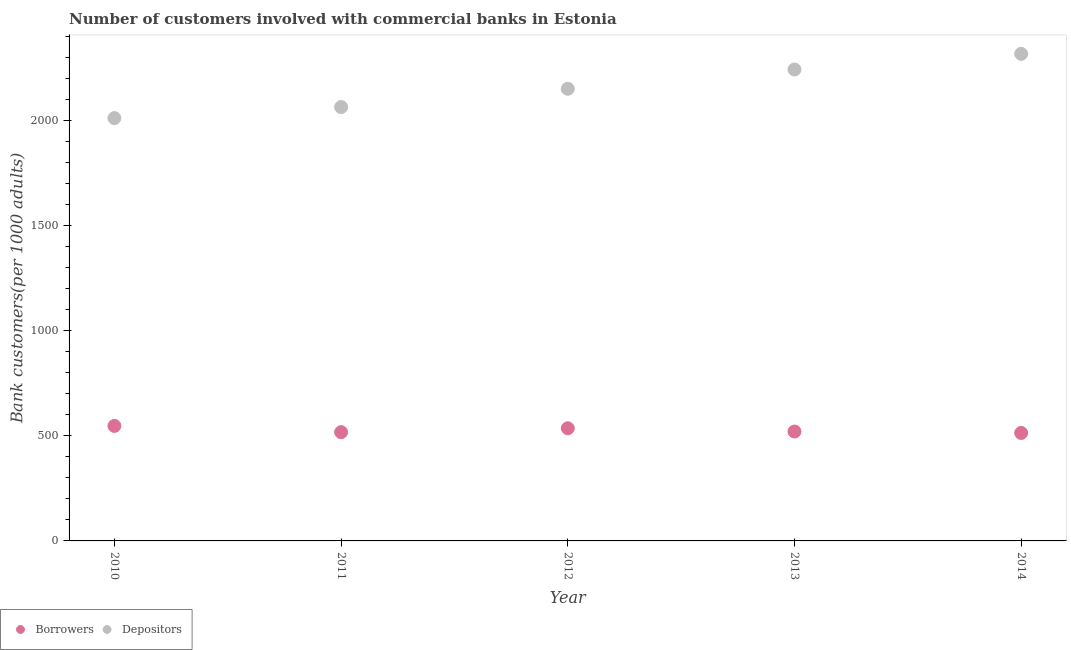How many different coloured dotlines are there?
Give a very brief answer. 2. Is the number of dotlines equal to the number of legend labels?
Make the answer very short. Yes. What is the number of depositors in 2011?
Provide a succinct answer. 2064.84. Across all years, what is the maximum number of borrowers?
Offer a very short reply. 547.32. Across all years, what is the minimum number of depositors?
Make the answer very short. 2012.21. What is the total number of borrowers in the graph?
Offer a terse response. 2635.42. What is the difference between the number of depositors in 2011 and that in 2013?
Your answer should be compact. -178.61. What is the difference between the number of borrowers in 2014 and the number of depositors in 2012?
Keep it short and to the point. -1637.88. What is the average number of depositors per year?
Give a very brief answer. 2158.03. In the year 2010, what is the difference between the number of depositors and number of borrowers?
Offer a very short reply. 1464.89. In how many years, is the number of borrowers greater than 2100?
Give a very brief answer. 0. What is the ratio of the number of borrowers in 2010 to that in 2012?
Offer a terse response. 1.02. Is the number of borrowers in 2010 less than that in 2014?
Provide a succinct answer. No. What is the difference between the highest and the second highest number of depositors?
Your answer should be very brief. 74.57. What is the difference between the highest and the lowest number of borrowers?
Your response must be concise. 33.53. Is the sum of the number of depositors in 2010 and 2014 greater than the maximum number of borrowers across all years?
Provide a succinct answer. Yes. Does the number of borrowers monotonically increase over the years?
Offer a terse response. No. Is the number of depositors strictly greater than the number of borrowers over the years?
Offer a very short reply. Yes. Is the number of borrowers strictly less than the number of depositors over the years?
Offer a terse response. Yes. How many dotlines are there?
Provide a short and direct response. 2. How many years are there in the graph?
Give a very brief answer. 5. What is the difference between two consecutive major ticks on the Y-axis?
Make the answer very short. 500. Does the graph contain any zero values?
Provide a succinct answer. No. Where does the legend appear in the graph?
Offer a terse response. Bottom left. What is the title of the graph?
Keep it short and to the point. Number of customers involved with commercial banks in Estonia. What is the label or title of the X-axis?
Offer a very short reply. Year. What is the label or title of the Y-axis?
Provide a succinct answer. Bank customers(per 1000 adults). What is the Bank customers(per 1000 adults) in Borrowers in 2010?
Your answer should be very brief. 547.32. What is the Bank customers(per 1000 adults) of Depositors in 2010?
Your answer should be very brief. 2012.21. What is the Bank customers(per 1000 adults) in Borrowers in 2011?
Your answer should be very brief. 517.65. What is the Bank customers(per 1000 adults) of Depositors in 2011?
Provide a short and direct response. 2064.84. What is the Bank customers(per 1000 adults) of Borrowers in 2012?
Offer a terse response. 536.16. What is the Bank customers(per 1000 adults) of Depositors in 2012?
Make the answer very short. 2151.67. What is the Bank customers(per 1000 adults) in Borrowers in 2013?
Offer a terse response. 520.5. What is the Bank customers(per 1000 adults) of Depositors in 2013?
Your response must be concise. 2243.44. What is the Bank customers(per 1000 adults) in Borrowers in 2014?
Ensure brevity in your answer.  513.79. What is the Bank customers(per 1000 adults) in Depositors in 2014?
Your answer should be very brief. 2318.01. Across all years, what is the maximum Bank customers(per 1000 adults) of Borrowers?
Ensure brevity in your answer.  547.32. Across all years, what is the maximum Bank customers(per 1000 adults) in Depositors?
Offer a terse response. 2318.01. Across all years, what is the minimum Bank customers(per 1000 adults) in Borrowers?
Keep it short and to the point. 513.79. Across all years, what is the minimum Bank customers(per 1000 adults) in Depositors?
Make the answer very short. 2012.21. What is the total Bank customers(per 1000 adults) in Borrowers in the graph?
Keep it short and to the point. 2635.42. What is the total Bank customers(per 1000 adults) in Depositors in the graph?
Offer a very short reply. 1.08e+04. What is the difference between the Bank customers(per 1000 adults) of Borrowers in 2010 and that in 2011?
Provide a short and direct response. 29.67. What is the difference between the Bank customers(per 1000 adults) in Depositors in 2010 and that in 2011?
Your answer should be very brief. -52.62. What is the difference between the Bank customers(per 1000 adults) of Borrowers in 2010 and that in 2012?
Ensure brevity in your answer.  11.16. What is the difference between the Bank customers(per 1000 adults) of Depositors in 2010 and that in 2012?
Your answer should be very brief. -139.46. What is the difference between the Bank customers(per 1000 adults) of Borrowers in 2010 and that in 2013?
Provide a short and direct response. 26.82. What is the difference between the Bank customers(per 1000 adults) in Depositors in 2010 and that in 2013?
Offer a terse response. -231.23. What is the difference between the Bank customers(per 1000 adults) in Borrowers in 2010 and that in 2014?
Your response must be concise. 33.53. What is the difference between the Bank customers(per 1000 adults) of Depositors in 2010 and that in 2014?
Give a very brief answer. -305.8. What is the difference between the Bank customers(per 1000 adults) of Borrowers in 2011 and that in 2012?
Make the answer very short. -18.51. What is the difference between the Bank customers(per 1000 adults) of Depositors in 2011 and that in 2012?
Your response must be concise. -86.83. What is the difference between the Bank customers(per 1000 adults) of Borrowers in 2011 and that in 2013?
Ensure brevity in your answer.  -2.85. What is the difference between the Bank customers(per 1000 adults) in Depositors in 2011 and that in 2013?
Offer a terse response. -178.61. What is the difference between the Bank customers(per 1000 adults) in Borrowers in 2011 and that in 2014?
Make the answer very short. 3.86. What is the difference between the Bank customers(per 1000 adults) in Depositors in 2011 and that in 2014?
Provide a short and direct response. -253.17. What is the difference between the Bank customers(per 1000 adults) in Borrowers in 2012 and that in 2013?
Keep it short and to the point. 15.66. What is the difference between the Bank customers(per 1000 adults) of Depositors in 2012 and that in 2013?
Your response must be concise. -91.77. What is the difference between the Bank customers(per 1000 adults) in Borrowers in 2012 and that in 2014?
Offer a terse response. 22.37. What is the difference between the Bank customers(per 1000 adults) in Depositors in 2012 and that in 2014?
Keep it short and to the point. -166.34. What is the difference between the Bank customers(per 1000 adults) in Borrowers in 2013 and that in 2014?
Give a very brief answer. 6.71. What is the difference between the Bank customers(per 1000 adults) of Depositors in 2013 and that in 2014?
Ensure brevity in your answer.  -74.57. What is the difference between the Bank customers(per 1000 adults) in Borrowers in 2010 and the Bank customers(per 1000 adults) in Depositors in 2011?
Ensure brevity in your answer.  -1517.52. What is the difference between the Bank customers(per 1000 adults) of Borrowers in 2010 and the Bank customers(per 1000 adults) of Depositors in 2012?
Give a very brief answer. -1604.35. What is the difference between the Bank customers(per 1000 adults) in Borrowers in 2010 and the Bank customers(per 1000 adults) in Depositors in 2013?
Provide a short and direct response. -1696.12. What is the difference between the Bank customers(per 1000 adults) of Borrowers in 2010 and the Bank customers(per 1000 adults) of Depositors in 2014?
Your response must be concise. -1770.69. What is the difference between the Bank customers(per 1000 adults) in Borrowers in 2011 and the Bank customers(per 1000 adults) in Depositors in 2012?
Offer a terse response. -1634.02. What is the difference between the Bank customers(per 1000 adults) of Borrowers in 2011 and the Bank customers(per 1000 adults) of Depositors in 2013?
Give a very brief answer. -1725.8. What is the difference between the Bank customers(per 1000 adults) in Borrowers in 2011 and the Bank customers(per 1000 adults) in Depositors in 2014?
Your answer should be very brief. -1800.36. What is the difference between the Bank customers(per 1000 adults) in Borrowers in 2012 and the Bank customers(per 1000 adults) in Depositors in 2013?
Make the answer very short. -1707.29. What is the difference between the Bank customers(per 1000 adults) of Borrowers in 2012 and the Bank customers(per 1000 adults) of Depositors in 2014?
Your answer should be very brief. -1781.85. What is the difference between the Bank customers(per 1000 adults) of Borrowers in 2013 and the Bank customers(per 1000 adults) of Depositors in 2014?
Your answer should be very brief. -1797.51. What is the average Bank customers(per 1000 adults) of Borrowers per year?
Your answer should be very brief. 527.08. What is the average Bank customers(per 1000 adults) of Depositors per year?
Provide a short and direct response. 2158.03. In the year 2010, what is the difference between the Bank customers(per 1000 adults) in Borrowers and Bank customers(per 1000 adults) in Depositors?
Make the answer very short. -1464.89. In the year 2011, what is the difference between the Bank customers(per 1000 adults) in Borrowers and Bank customers(per 1000 adults) in Depositors?
Your response must be concise. -1547.19. In the year 2012, what is the difference between the Bank customers(per 1000 adults) in Borrowers and Bank customers(per 1000 adults) in Depositors?
Provide a succinct answer. -1615.51. In the year 2013, what is the difference between the Bank customers(per 1000 adults) in Borrowers and Bank customers(per 1000 adults) in Depositors?
Your answer should be compact. -1722.95. In the year 2014, what is the difference between the Bank customers(per 1000 adults) of Borrowers and Bank customers(per 1000 adults) of Depositors?
Make the answer very short. -1804.22. What is the ratio of the Bank customers(per 1000 adults) of Borrowers in 2010 to that in 2011?
Give a very brief answer. 1.06. What is the ratio of the Bank customers(per 1000 adults) of Depositors in 2010 to that in 2011?
Provide a succinct answer. 0.97. What is the ratio of the Bank customers(per 1000 adults) in Borrowers in 2010 to that in 2012?
Your answer should be very brief. 1.02. What is the ratio of the Bank customers(per 1000 adults) of Depositors in 2010 to that in 2012?
Offer a very short reply. 0.94. What is the ratio of the Bank customers(per 1000 adults) of Borrowers in 2010 to that in 2013?
Your response must be concise. 1.05. What is the ratio of the Bank customers(per 1000 adults) of Depositors in 2010 to that in 2013?
Your answer should be very brief. 0.9. What is the ratio of the Bank customers(per 1000 adults) in Borrowers in 2010 to that in 2014?
Make the answer very short. 1.07. What is the ratio of the Bank customers(per 1000 adults) in Depositors in 2010 to that in 2014?
Ensure brevity in your answer.  0.87. What is the ratio of the Bank customers(per 1000 adults) in Borrowers in 2011 to that in 2012?
Your response must be concise. 0.97. What is the ratio of the Bank customers(per 1000 adults) of Depositors in 2011 to that in 2012?
Ensure brevity in your answer.  0.96. What is the ratio of the Bank customers(per 1000 adults) in Depositors in 2011 to that in 2013?
Your answer should be very brief. 0.92. What is the ratio of the Bank customers(per 1000 adults) of Borrowers in 2011 to that in 2014?
Make the answer very short. 1.01. What is the ratio of the Bank customers(per 1000 adults) of Depositors in 2011 to that in 2014?
Offer a very short reply. 0.89. What is the ratio of the Bank customers(per 1000 adults) of Borrowers in 2012 to that in 2013?
Make the answer very short. 1.03. What is the ratio of the Bank customers(per 1000 adults) of Depositors in 2012 to that in 2013?
Provide a succinct answer. 0.96. What is the ratio of the Bank customers(per 1000 adults) in Borrowers in 2012 to that in 2014?
Offer a very short reply. 1.04. What is the ratio of the Bank customers(per 1000 adults) of Depositors in 2012 to that in 2014?
Offer a terse response. 0.93. What is the ratio of the Bank customers(per 1000 adults) in Borrowers in 2013 to that in 2014?
Your answer should be very brief. 1.01. What is the ratio of the Bank customers(per 1000 adults) in Depositors in 2013 to that in 2014?
Ensure brevity in your answer.  0.97. What is the difference between the highest and the second highest Bank customers(per 1000 adults) of Borrowers?
Give a very brief answer. 11.16. What is the difference between the highest and the second highest Bank customers(per 1000 adults) of Depositors?
Your answer should be very brief. 74.57. What is the difference between the highest and the lowest Bank customers(per 1000 adults) in Borrowers?
Provide a succinct answer. 33.53. What is the difference between the highest and the lowest Bank customers(per 1000 adults) of Depositors?
Offer a very short reply. 305.8. 